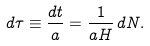<formula> <loc_0><loc_0><loc_500><loc_500>d \tau \equiv \frac { d t } { a } = \frac { 1 } { a H } \, d N .</formula> 